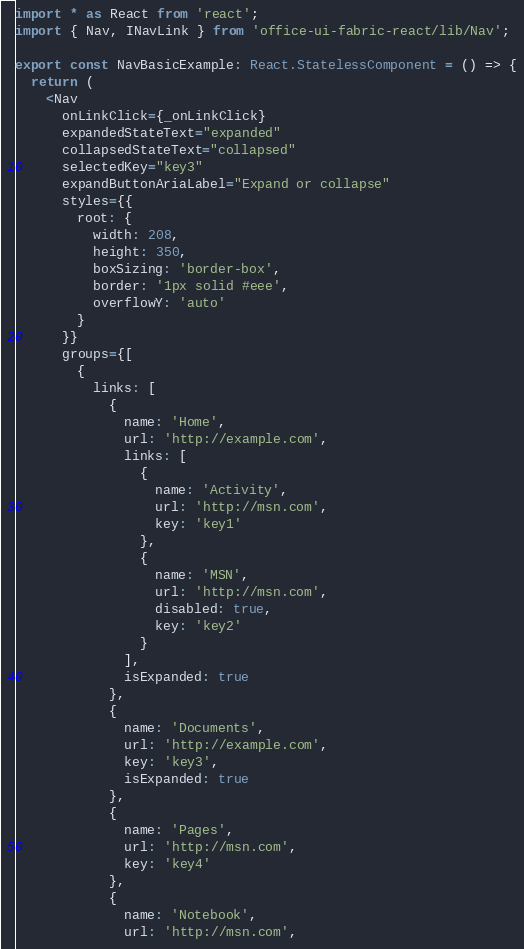<code> <loc_0><loc_0><loc_500><loc_500><_TypeScript_>import * as React from 'react';
import { Nav, INavLink } from 'office-ui-fabric-react/lib/Nav';

export const NavBasicExample: React.StatelessComponent = () => {
  return (
    <Nav
      onLinkClick={_onLinkClick}
      expandedStateText="expanded"
      collapsedStateText="collapsed"
      selectedKey="key3"
      expandButtonAriaLabel="Expand or collapse"
      styles={{
        root: {
          width: 208,
          height: 350,
          boxSizing: 'border-box',
          border: '1px solid #eee',
          overflowY: 'auto'
        }
      }}
      groups={[
        {
          links: [
            {
              name: 'Home',
              url: 'http://example.com',
              links: [
                {
                  name: 'Activity',
                  url: 'http://msn.com',
                  key: 'key1'
                },
                {
                  name: 'MSN',
                  url: 'http://msn.com',
                  disabled: true,
                  key: 'key2'
                }
              ],
              isExpanded: true
            },
            {
              name: 'Documents',
              url: 'http://example.com',
              key: 'key3',
              isExpanded: true
            },
            {
              name: 'Pages',
              url: 'http://msn.com',
              key: 'key4'
            },
            {
              name: 'Notebook',
              url: 'http://msn.com',</code> 